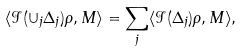<formula> <loc_0><loc_0><loc_500><loc_500>\langle \mathcal { I } ( \cup _ { j } \Delta _ { j } ) \rho , M \rangle = \sum _ { j } \langle \mathcal { I } ( \Delta _ { j } ) \rho , M \rangle ,</formula> 